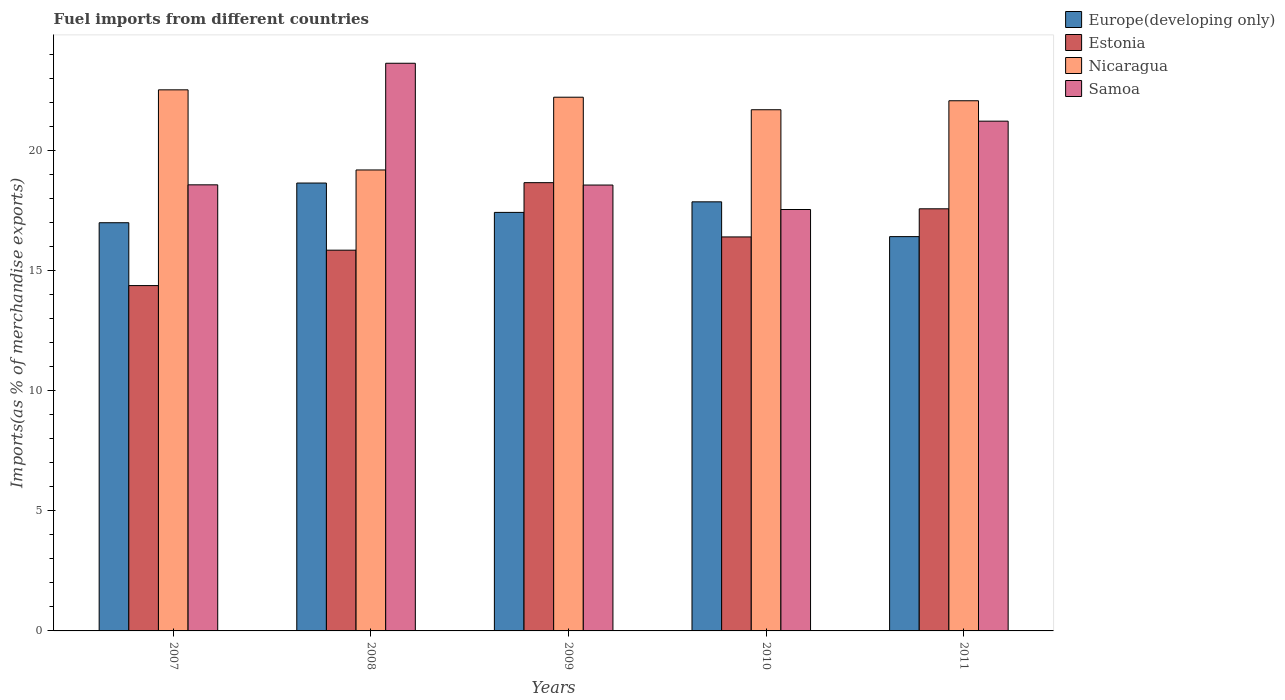How many different coloured bars are there?
Make the answer very short. 4. How many groups of bars are there?
Keep it short and to the point. 5. Are the number of bars per tick equal to the number of legend labels?
Your response must be concise. Yes. Are the number of bars on each tick of the X-axis equal?
Offer a very short reply. Yes. How many bars are there on the 4th tick from the left?
Provide a short and direct response. 4. What is the label of the 5th group of bars from the left?
Your answer should be very brief. 2011. In how many cases, is the number of bars for a given year not equal to the number of legend labels?
Provide a short and direct response. 0. What is the percentage of imports to different countries in Estonia in 2007?
Offer a very short reply. 14.39. Across all years, what is the maximum percentage of imports to different countries in Estonia?
Make the answer very short. 18.67. Across all years, what is the minimum percentage of imports to different countries in Samoa?
Provide a short and direct response. 17.56. In which year was the percentage of imports to different countries in Europe(developing only) maximum?
Give a very brief answer. 2008. What is the total percentage of imports to different countries in Europe(developing only) in the graph?
Offer a terse response. 87.4. What is the difference between the percentage of imports to different countries in Nicaragua in 2008 and that in 2011?
Offer a terse response. -2.88. What is the difference between the percentage of imports to different countries in Samoa in 2008 and the percentage of imports to different countries in Estonia in 2009?
Provide a short and direct response. 4.97. What is the average percentage of imports to different countries in Europe(developing only) per year?
Make the answer very short. 17.48. In the year 2009, what is the difference between the percentage of imports to different countries in Estonia and percentage of imports to different countries in Nicaragua?
Provide a short and direct response. -3.56. In how many years, is the percentage of imports to different countries in Europe(developing only) greater than 20 %?
Your answer should be compact. 0. What is the ratio of the percentage of imports to different countries in Estonia in 2009 to that in 2010?
Your answer should be compact. 1.14. What is the difference between the highest and the second highest percentage of imports to different countries in Estonia?
Your answer should be compact. 1.09. What is the difference between the highest and the lowest percentage of imports to different countries in Samoa?
Your response must be concise. 6.09. What does the 3rd bar from the left in 2011 represents?
Your response must be concise. Nicaragua. What does the 2nd bar from the right in 2009 represents?
Offer a terse response. Nicaragua. How many bars are there?
Offer a terse response. 20. Are all the bars in the graph horizontal?
Provide a short and direct response. No. How many years are there in the graph?
Your response must be concise. 5. What is the difference between two consecutive major ticks on the Y-axis?
Give a very brief answer. 5. Where does the legend appear in the graph?
Your response must be concise. Top right. What is the title of the graph?
Keep it short and to the point. Fuel imports from different countries. Does "World" appear as one of the legend labels in the graph?
Keep it short and to the point. No. What is the label or title of the X-axis?
Provide a short and direct response. Years. What is the label or title of the Y-axis?
Your response must be concise. Imports(as % of merchandise exports). What is the Imports(as % of merchandise exports) in Europe(developing only) in 2007?
Give a very brief answer. 17.01. What is the Imports(as % of merchandise exports) of Estonia in 2007?
Offer a terse response. 14.39. What is the Imports(as % of merchandise exports) of Nicaragua in 2007?
Provide a short and direct response. 22.54. What is the Imports(as % of merchandise exports) in Samoa in 2007?
Provide a short and direct response. 18.58. What is the Imports(as % of merchandise exports) of Europe(developing only) in 2008?
Your answer should be compact. 18.66. What is the Imports(as % of merchandise exports) of Estonia in 2008?
Your response must be concise. 15.86. What is the Imports(as % of merchandise exports) in Nicaragua in 2008?
Offer a very short reply. 19.2. What is the Imports(as % of merchandise exports) of Samoa in 2008?
Give a very brief answer. 23.65. What is the Imports(as % of merchandise exports) of Europe(developing only) in 2009?
Your answer should be very brief. 17.44. What is the Imports(as % of merchandise exports) in Estonia in 2009?
Give a very brief answer. 18.67. What is the Imports(as % of merchandise exports) of Nicaragua in 2009?
Make the answer very short. 22.24. What is the Imports(as % of merchandise exports) in Samoa in 2009?
Provide a short and direct response. 18.58. What is the Imports(as % of merchandise exports) of Europe(developing only) in 2010?
Keep it short and to the point. 17.88. What is the Imports(as % of merchandise exports) of Estonia in 2010?
Your answer should be very brief. 16.41. What is the Imports(as % of merchandise exports) of Nicaragua in 2010?
Offer a very short reply. 21.71. What is the Imports(as % of merchandise exports) of Samoa in 2010?
Provide a short and direct response. 17.56. What is the Imports(as % of merchandise exports) of Europe(developing only) in 2011?
Your response must be concise. 16.43. What is the Imports(as % of merchandise exports) of Estonia in 2011?
Your answer should be compact. 17.59. What is the Imports(as % of merchandise exports) in Nicaragua in 2011?
Your response must be concise. 22.09. What is the Imports(as % of merchandise exports) of Samoa in 2011?
Make the answer very short. 21.24. Across all years, what is the maximum Imports(as % of merchandise exports) in Europe(developing only)?
Give a very brief answer. 18.66. Across all years, what is the maximum Imports(as % of merchandise exports) of Estonia?
Make the answer very short. 18.67. Across all years, what is the maximum Imports(as % of merchandise exports) of Nicaragua?
Provide a succinct answer. 22.54. Across all years, what is the maximum Imports(as % of merchandise exports) in Samoa?
Ensure brevity in your answer.  23.65. Across all years, what is the minimum Imports(as % of merchandise exports) of Europe(developing only)?
Make the answer very short. 16.43. Across all years, what is the minimum Imports(as % of merchandise exports) of Estonia?
Make the answer very short. 14.39. Across all years, what is the minimum Imports(as % of merchandise exports) of Nicaragua?
Ensure brevity in your answer.  19.2. Across all years, what is the minimum Imports(as % of merchandise exports) in Samoa?
Ensure brevity in your answer.  17.56. What is the total Imports(as % of merchandise exports) in Europe(developing only) in the graph?
Offer a terse response. 87.4. What is the total Imports(as % of merchandise exports) in Estonia in the graph?
Make the answer very short. 82.92. What is the total Imports(as % of merchandise exports) of Nicaragua in the graph?
Offer a very short reply. 107.78. What is the total Imports(as % of merchandise exports) in Samoa in the graph?
Your answer should be very brief. 99.6. What is the difference between the Imports(as % of merchandise exports) of Europe(developing only) in 2007 and that in 2008?
Make the answer very short. -1.65. What is the difference between the Imports(as % of merchandise exports) in Estonia in 2007 and that in 2008?
Ensure brevity in your answer.  -1.48. What is the difference between the Imports(as % of merchandise exports) of Nicaragua in 2007 and that in 2008?
Your answer should be compact. 3.34. What is the difference between the Imports(as % of merchandise exports) of Samoa in 2007 and that in 2008?
Offer a very short reply. -5.06. What is the difference between the Imports(as % of merchandise exports) of Europe(developing only) in 2007 and that in 2009?
Make the answer very short. -0.43. What is the difference between the Imports(as % of merchandise exports) of Estonia in 2007 and that in 2009?
Make the answer very short. -4.29. What is the difference between the Imports(as % of merchandise exports) of Nicaragua in 2007 and that in 2009?
Offer a terse response. 0.31. What is the difference between the Imports(as % of merchandise exports) in Samoa in 2007 and that in 2009?
Give a very brief answer. 0.01. What is the difference between the Imports(as % of merchandise exports) in Europe(developing only) in 2007 and that in 2010?
Your response must be concise. -0.87. What is the difference between the Imports(as % of merchandise exports) of Estonia in 2007 and that in 2010?
Give a very brief answer. -2.03. What is the difference between the Imports(as % of merchandise exports) in Nicaragua in 2007 and that in 2010?
Ensure brevity in your answer.  0.83. What is the difference between the Imports(as % of merchandise exports) of Samoa in 2007 and that in 2010?
Offer a very short reply. 1.03. What is the difference between the Imports(as % of merchandise exports) of Europe(developing only) in 2007 and that in 2011?
Your answer should be very brief. 0.58. What is the difference between the Imports(as % of merchandise exports) of Estonia in 2007 and that in 2011?
Your answer should be very brief. -3.2. What is the difference between the Imports(as % of merchandise exports) of Nicaragua in 2007 and that in 2011?
Provide a short and direct response. 0.46. What is the difference between the Imports(as % of merchandise exports) of Samoa in 2007 and that in 2011?
Ensure brevity in your answer.  -2.65. What is the difference between the Imports(as % of merchandise exports) in Europe(developing only) in 2008 and that in 2009?
Offer a very short reply. 1.22. What is the difference between the Imports(as % of merchandise exports) in Estonia in 2008 and that in 2009?
Ensure brevity in your answer.  -2.81. What is the difference between the Imports(as % of merchandise exports) in Nicaragua in 2008 and that in 2009?
Make the answer very short. -3.03. What is the difference between the Imports(as % of merchandise exports) of Samoa in 2008 and that in 2009?
Ensure brevity in your answer.  5.07. What is the difference between the Imports(as % of merchandise exports) of Europe(developing only) in 2008 and that in 2010?
Your answer should be very brief. 0.78. What is the difference between the Imports(as % of merchandise exports) of Estonia in 2008 and that in 2010?
Keep it short and to the point. -0.55. What is the difference between the Imports(as % of merchandise exports) in Nicaragua in 2008 and that in 2010?
Offer a terse response. -2.51. What is the difference between the Imports(as % of merchandise exports) of Samoa in 2008 and that in 2010?
Provide a succinct answer. 6.09. What is the difference between the Imports(as % of merchandise exports) in Europe(developing only) in 2008 and that in 2011?
Offer a very short reply. 2.23. What is the difference between the Imports(as % of merchandise exports) in Estonia in 2008 and that in 2011?
Offer a very short reply. -1.72. What is the difference between the Imports(as % of merchandise exports) of Nicaragua in 2008 and that in 2011?
Provide a succinct answer. -2.88. What is the difference between the Imports(as % of merchandise exports) in Samoa in 2008 and that in 2011?
Offer a terse response. 2.41. What is the difference between the Imports(as % of merchandise exports) in Europe(developing only) in 2009 and that in 2010?
Ensure brevity in your answer.  -0.44. What is the difference between the Imports(as % of merchandise exports) of Estonia in 2009 and that in 2010?
Give a very brief answer. 2.26. What is the difference between the Imports(as % of merchandise exports) in Nicaragua in 2009 and that in 2010?
Keep it short and to the point. 0.52. What is the difference between the Imports(as % of merchandise exports) of Samoa in 2009 and that in 2010?
Offer a terse response. 1.02. What is the difference between the Imports(as % of merchandise exports) of Europe(developing only) in 2009 and that in 2011?
Offer a terse response. 1.01. What is the difference between the Imports(as % of merchandise exports) of Estonia in 2009 and that in 2011?
Make the answer very short. 1.09. What is the difference between the Imports(as % of merchandise exports) of Nicaragua in 2009 and that in 2011?
Offer a very short reply. 0.15. What is the difference between the Imports(as % of merchandise exports) in Samoa in 2009 and that in 2011?
Provide a short and direct response. -2.66. What is the difference between the Imports(as % of merchandise exports) in Europe(developing only) in 2010 and that in 2011?
Offer a terse response. 1.45. What is the difference between the Imports(as % of merchandise exports) in Estonia in 2010 and that in 2011?
Ensure brevity in your answer.  -1.17. What is the difference between the Imports(as % of merchandise exports) of Nicaragua in 2010 and that in 2011?
Your answer should be compact. -0.37. What is the difference between the Imports(as % of merchandise exports) in Samoa in 2010 and that in 2011?
Provide a short and direct response. -3.68. What is the difference between the Imports(as % of merchandise exports) of Europe(developing only) in 2007 and the Imports(as % of merchandise exports) of Estonia in 2008?
Your answer should be very brief. 1.14. What is the difference between the Imports(as % of merchandise exports) in Europe(developing only) in 2007 and the Imports(as % of merchandise exports) in Nicaragua in 2008?
Offer a terse response. -2.2. What is the difference between the Imports(as % of merchandise exports) in Europe(developing only) in 2007 and the Imports(as % of merchandise exports) in Samoa in 2008?
Give a very brief answer. -6.64. What is the difference between the Imports(as % of merchandise exports) of Estonia in 2007 and the Imports(as % of merchandise exports) of Nicaragua in 2008?
Ensure brevity in your answer.  -4.82. What is the difference between the Imports(as % of merchandise exports) of Estonia in 2007 and the Imports(as % of merchandise exports) of Samoa in 2008?
Keep it short and to the point. -9.26. What is the difference between the Imports(as % of merchandise exports) of Nicaragua in 2007 and the Imports(as % of merchandise exports) of Samoa in 2008?
Provide a short and direct response. -1.11. What is the difference between the Imports(as % of merchandise exports) of Europe(developing only) in 2007 and the Imports(as % of merchandise exports) of Estonia in 2009?
Offer a very short reply. -1.67. What is the difference between the Imports(as % of merchandise exports) of Europe(developing only) in 2007 and the Imports(as % of merchandise exports) of Nicaragua in 2009?
Your answer should be compact. -5.23. What is the difference between the Imports(as % of merchandise exports) in Europe(developing only) in 2007 and the Imports(as % of merchandise exports) in Samoa in 2009?
Your answer should be very brief. -1.57. What is the difference between the Imports(as % of merchandise exports) of Estonia in 2007 and the Imports(as % of merchandise exports) of Nicaragua in 2009?
Keep it short and to the point. -7.85. What is the difference between the Imports(as % of merchandise exports) of Estonia in 2007 and the Imports(as % of merchandise exports) of Samoa in 2009?
Keep it short and to the point. -4.19. What is the difference between the Imports(as % of merchandise exports) of Nicaragua in 2007 and the Imports(as % of merchandise exports) of Samoa in 2009?
Provide a short and direct response. 3.97. What is the difference between the Imports(as % of merchandise exports) in Europe(developing only) in 2007 and the Imports(as % of merchandise exports) in Estonia in 2010?
Your answer should be very brief. 0.59. What is the difference between the Imports(as % of merchandise exports) in Europe(developing only) in 2007 and the Imports(as % of merchandise exports) in Nicaragua in 2010?
Your response must be concise. -4.71. What is the difference between the Imports(as % of merchandise exports) in Europe(developing only) in 2007 and the Imports(as % of merchandise exports) in Samoa in 2010?
Offer a terse response. -0.55. What is the difference between the Imports(as % of merchandise exports) in Estonia in 2007 and the Imports(as % of merchandise exports) in Nicaragua in 2010?
Ensure brevity in your answer.  -7.33. What is the difference between the Imports(as % of merchandise exports) in Estonia in 2007 and the Imports(as % of merchandise exports) in Samoa in 2010?
Offer a very short reply. -3.17. What is the difference between the Imports(as % of merchandise exports) in Nicaragua in 2007 and the Imports(as % of merchandise exports) in Samoa in 2010?
Your response must be concise. 4.99. What is the difference between the Imports(as % of merchandise exports) in Europe(developing only) in 2007 and the Imports(as % of merchandise exports) in Estonia in 2011?
Your answer should be very brief. -0.58. What is the difference between the Imports(as % of merchandise exports) of Europe(developing only) in 2007 and the Imports(as % of merchandise exports) of Nicaragua in 2011?
Give a very brief answer. -5.08. What is the difference between the Imports(as % of merchandise exports) in Europe(developing only) in 2007 and the Imports(as % of merchandise exports) in Samoa in 2011?
Give a very brief answer. -4.23. What is the difference between the Imports(as % of merchandise exports) in Estonia in 2007 and the Imports(as % of merchandise exports) in Nicaragua in 2011?
Keep it short and to the point. -7.7. What is the difference between the Imports(as % of merchandise exports) of Estonia in 2007 and the Imports(as % of merchandise exports) of Samoa in 2011?
Your answer should be compact. -6.85. What is the difference between the Imports(as % of merchandise exports) in Nicaragua in 2007 and the Imports(as % of merchandise exports) in Samoa in 2011?
Provide a succinct answer. 1.31. What is the difference between the Imports(as % of merchandise exports) of Europe(developing only) in 2008 and the Imports(as % of merchandise exports) of Estonia in 2009?
Keep it short and to the point. -0.01. What is the difference between the Imports(as % of merchandise exports) in Europe(developing only) in 2008 and the Imports(as % of merchandise exports) in Nicaragua in 2009?
Ensure brevity in your answer.  -3.58. What is the difference between the Imports(as % of merchandise exports) in Europe(developing only) in 2008 and the Imports(as % of merchandise exports) in Samoa in 2009?
Keep it short and to the point. 0.08. What is the difference between the Imports(as % of merchandise exports) of Estonia in 2008 and the Imports(as % of merchandise exports) of Nicaragua in 2009?
Your answer should be very brief. -6.37. What is the difference between the Imports(as % of merchandise exports) of Estonia in 2008 and the Imports(as % of merchandise exports) of Samoa in 2009?
Give a very brief answer. -2.71. What is the difference between the Imports(as % of merchandise exports) of Nicaragua in 2008 and the Imports(as % of merchandise exports) of Samoa in 2009?
Your answer should be compact. 0.63. What is the difference between the Imports(as % of merchandise exports) in Europe(developing only) in 2008 and the Imports(as % of merchandise exports) in Estonia in 2010?
Provide a short and direct response. 2.25. What is the difference between the Imports(as % of merchandise exports) of Europe(developing only) in 2008 and the Imports(as % of merchandise exports) of Nicaragua in 2010?
Give a very brief answer. -3.05. What is the difference between the Imports(as % of merchandise exports) of Europe(developing only) in 2008 and the Imports(as % of merchandise exports) of Samoa in 2010?
Provide a short and direct response. 1.1. What is the difference between the Imports(as % of merchandise exports) of Estonia in 2008 and the Imports(as % of merchandise exports) of Nicaragua in 2010?
Offer a terse response. -5.85. What is the difference between the Imports(as % of merchandise exports) in Estonia in 2008 and the Imports(as % of merchandise exports) in Samoa in 2010?
Make the answer very short. -1.69. What is the difference between the Imports(as % of merchandise exports) in Nicaragua in 2008 and the Imports(as % of merchandise exports) in Samoa in 2010?
Offer a terse response. 1.65. What is the difference between the Imports(as % of merchandise exports) in Europe(developing only) in 2008 and the Imports(as % of merchandise exports) in Estonia in 2011?
Keep it short and to the point. 1.07. What is the difference between the Imports(as % of merchandise exports) of Europe(developing only) in 2008 and the Imports(as % of merchandise exports) of Nicaragua in 2011?
Make the answer very short. -3.43. What is the difference between the Imports(as % of merchandise exports) in Europe(developing only) in 2008 and the Imports(as % of merchandise exports) in Samoa in 2011?
Your answer should be compact. -2.58. What is the difference between the Imports(as % of merchandise exports) of Estonia in 2008 and the Imports(as % of merchandise exports) of Nicaragua in 2011?
Provide a short and direct response. -6.22. What is the difference between the Imports(as % of merchandise exports) in Estonia in 2008 and the Imports(as % of merchandise exports) in Samoa in 2011?
Keep it short and to the point. -5.37. What is the difference between the Imports(as % of merchandise exports) in Nicaragua in 2008 and the Imports(as % of merchandise exports) in Samoa in 2011?
Give a very brief answer. -2.03. What is the difference between the Imports(as % of merchandise exports) in Europe(developing only) in 2009 and the Imports(as % of merchandise exports) in Estonia in 2010?
Your answer should be compact. 1.02. What is the difference between the Imports(as % of merchandise exports) in Europe(developing only) in 2009 and the Imports(as % of merchandise exports) in Nicaragua in 2010?
Keep it short and to the point. -4.28. What is the difference between the Imports(as % of merchandise exports) in Europe(developing only) in 2009 and the Imports(as % of merchandise exports) in Samoa in 2010?
Offer a very short reply. -0.12. What is the difference between the Imports(as % of merchandise exports) of Estonia in 2009 and the Imports(as % of merchandise exports) of Nicaragua in 2010?
Offer a very short reply. -3.04. What is the difference between the Imports(as % of merchandise exports) in Estonia in 2009 and the Imports(as % of merchandise exports) in Samoa in 2010?
Keep it short and to the point. 1.12. What is the difference between the Imports(as % of merchandise exports) in Nicaragua in 2009 and the Imports(as % of merchandise exports) in Samoa in 2010?
Provide a succinct answer. 4.68. What is the difference between the Imports(as % of merchandise exports) of Europe(developing only) in 2009 and the Imports(as % of merchandise exports) of Estonia in 2011?
Your response must be concise. -0.15. What is the difference between the Imports(as % of merchandise exports) of Europe(developing only) in 2009 and the Imports(as % of merchandise exports) of Nicaragua in 2011?
Make the answer very short. -4.65. What is the difference between the Imports(as % of merchandise exports) in Europe(developing only) in 2009 and the Imports(as % of merchandise exports) in Samoa in 2011?
Make the answer very short. -3.8. What is the difference between the Imports(as % of merchandise exports) of Estonia in 2009 and the Imports(as % of merchandise exports) of Nicaragua in 2011?
Make the answer very short. -3.41. What is the difference between the Imports(as % of merchandise exports) of Estonia in 2009 and the Imports(as % of merchandise exports) of Samoa in 2011?
Your answer should be compact. -2.56. What is the difference between the Imports(as % of merchandise exports) of Nicaragua in 2009 and the Imports(as % of merchandise exports) of Samoa in 2011?
Offer a very short reply. 1. What is the difference between the Imports(as % of merchandise exports) in Europe(developing only) in 2010 and the Imports(as % of merchandise exports) in Estonia in 2011?
Your answer should be compact. 0.29. What is the difference between the Imports(as % of merchandise exports) in Europe(developing only) in 2010 and the Imports(as % of merchandise exports) in Nicaragua in 2011?
Make the answer very short. -4.21. What is the difference between the Imports(as % of merchandise exports) of Europe(developing only) in 2010 and the Imports(as % of merchandise exports) of Samoa in 2011?
Provide a short and direct response. -3.36. What is the difference between the Imports(as % of merchandise exports) in Estonia in 2010 and the Imports(as % of merchandise exports) in Nicaragua in 2011?
Make the answer very short. -5.67. What is the difference between the Imports(as % of merchandise exports) of Estonia in 2010 and the Imports(as % of merchandise exports) of Samoa in 2011?
Your response must be concise. -4.82. What is the difference between the Imports(as % of merchandise exports) of Nicaragua in 2010 and the Imports(as % of merchandise exports) of Samoa in 2011?
Ensure brevity in your answer.  0.48. What is the average Imports(as % of merchandise exports) in Europe(developing only) per year?
Provide a succinct answer. 17.48. What is the average Imports(as % of merchandise exports) in Estonia per year?
Offer a very short reply. 16.58. What is the average Imports(as % of merchandise exports) of Nicaragua per year?
Provide a succinct answer. 21.56. What is the average Imports(as % of merchandise exports) of Samoa per year?
Make the answer very short. 19.92. In the year 2007, what is the difference between the Imports(as % of merchandise exports) of Europe(developing only) and Imports(as % of merchandise exports) of Estonia?
Your answer should be very brief. 2.62. In the year 2007, what is the difference between the Imports(as % of merchandise exports) of Europe(developing only) and Imports(as % of merchandise exports) of Nicaragua?
Provide a short and direct response. -5.54. In the year 2007, what is the difference between the Imports(as % of merchandise exports) in Europe(developing only) and Imports(as % of merchandise exports) in Samoa?
Your answer should be compact. -1.58. In the year 2007, what is the difference between the Imports(as % of merchandise exports) in Estonia and Imports(as % of merchandise exports) in Nicaragua?
Ensure brevity in your answer.  -8.16. In the year 2007, what is the difference between the Imports(as % of merchandise exports) in Estonia and Imports(as % of merchandise exports) in Samoa?
Provide a short and direct response. -4.2. In the year 2007, what is the difference between the Imports(as % of merchandise exports) of Nicaragua and Imports(as % of merchandise exports) of Samoa?
Your answer should be compact. 3.96. In the year 2008, what is the difference between the Imports(as % of merchandise exports) of Europe(developing only) and Imports(as % of merchandise exports) of Estonia?
Offer a terse response. 2.8. In the year 2008, what is the difference between the Imports(as % of merchandise exports) of Europe(developing only) and Imports(as % of merchandise exports) of Nicaragua?
Offer a very short reply. -0.54. In the year 2008, what is the difference between the Imports(as % of merchandise exports) in Europe(developing only) and Imports(as % of merchandise exports) in Samoa?
Keep it short and to the point. -4.99. In the year 2008, what is the difference between the Imports(as % of merchandise exports) in Estonia and Imports(as % of merchandise exports) in Nicaragua?
Your response must be concise. -3.34. In the year 2008, what is the difference between the Imports(as % of merchandise exports) of Estonia and Imports(as % of merchandise exports) of Samoa?
Provide a short and direct response. -7.79. In the year 2008, what is the difference between the Imports(as % of merchandise exports) of Nicaragua and Imports(as % of merchandise exports) of Samoa?
Make the answer very short. -4.45. In the year 2009, what is the difference between the Imports(as % of merchandise exports) in Europe(developing only) and Imports(as % of merchandise exports) in Estonia?
Your answer should be very brief. -1.24. In the year 2009, what is the difference between the Imports(as % of merchandise exports) of Europe(developing only) and Imports(as % of merchandise exports) of Nicaragua?
Provide a short and direct response. -4.8. In the year 2009, what is the difference between the Imports(as % of merchandise exports) in Europe(developing only) and Imports(as % of merchandise exports) in Samoa?
Offer a very short reply. -1.14. In the year 2009, what is the difference between the Imports(as % of merchandise exports) in Estonia and Imports(as % of merchandise exports) in Nicaragua?
Provide a succinct answer. -3.56. In the year 2009, what is the difference between the Imports(as % of merchandise exports) of Estonia and Imports(as % of merchandise exports) of Samoa?
Provide a succinct answer. 0.1. In the year 2009, what is the difference between the Imports(as % of merchandise exports) of Nicaragua and Imports(as % of merchandise exports) of Samoa?
Give a very brief answer. 3.66. In the year 2010, what is the difference between the Imports(as % of merchandise exports) in Europe(developing only) and Imports(as % of merchandise exports) in Estonia?
Make the answer very short. 1.46. In the year 2010, what is the difference between the Imports(as % of merchandise exports) in Europe(developing only) and Imports(as % of merchandise exports) in Nicaragua?
Offer a very short reply. -3.84. In the year 2010, what is the difference between the Imports(as % of merchandise exports) of Europe(developing only) and Imports(as % of merchandise exports) of Samoa?
Give a very brief answer. 0.32. In the year 2010, what is the difference between the Imports(as % of merchandise exports) in Estonia and Imports(as % of merchandise exports) in Nicaragua?
Your response must be concise. -5.3. In the year 2010, what is the difference between the Imports(as % of merchandise exports) of Estonia and Imports(as % of merchandise exports) of Samoa?
Make the answer very short. -1.14. In the year 2010, what is the difference between the Imports(as % of merchandise exports) in Nicaragua and Imports(as % of merchandise exports) in Samoa?
Keep it short and to the point. 4.16. In the year 2011, what is the difference between the Imports(as % of merchandise exports) in Europe(developing only) and Imports(as % of merchandise exports) in Estonia?
Keep it short and to the point. -1.16. In the year 2011, what is the difference between the Imports(as % of merchandise exports) in Europe(developing only) and Imports(as % of merchandise exports) in Nicaragua?
Make the answer very short. -5.66. In the year 2011, what is the difference between the Imports(as % of merchandise exports) of Europe(developing only) and Imports(as % of merchandise exports) of Samoa?
Give a very brief answer. -4.81. In the year 2011, what is the difference between the Imports(as % of merchandise exports) of Estonia and Imports(as % of merchandise exports) of Nicaragua?
Your response must be concise. -4.5. In the year 2011, what is the difference between the Imports(as % of merchandise exports) of Estonia and Imports(as % of merchandise exports) of Samoa?
Provide a succinct answer. -3.65. In the year 2011, what is the difference between the Imports(as % of merchandise exports) in Nicaragua and Imports(as % of merchandise exports) in Samoa?
Your answer should be very brief. 0.85. What is the ratio of the Imports(as % of merchandise exports) of Europe(developing only) in 2007 to that in 2008?
Provide a short and direct response. 0.91. What is the ratio of the Imports(as % of merchandise exports) in Estonia in 2007 to that in 2008?
Keep it short and to the point. 0.91. What is the ratio of the Imports(as % of merchandise exports) in Nicaragua in 2007 to that in 2008?
Your response must be concise. 1.17. What is the ratio of the Imports(as % of merchandise exports) of Samoa in 2007 to that in 2008?
Keep it short and to the point. 0.79. What is the ratio of the Imports(as % of merchandise exports) in Europe(developing only) in 2007 to that in 2009?
Offer a terse response. 0.98. What is the ratio of the Imports(as % of merchandise exports) of Estonia in 2007 to that in 2009?
Your answer should be very brief. 0.77. What is the ratio of the Imports(as % of merchandise exports) in Nicaragua in 2007 to that in 2009?
Offer a very short reply. 1.01. What is the ratio of the Imports(as % of merchandise exports) of Samoa in 2007 to that in 2009?
Provide a short and direct response. 1. What is the ratio of the Imports(as % of merchandise exports) in Europe(developing only) in 2007 to that in 2010?
Provide a succinct answer. 0.95. What is the ratio of the Imports(as % of merchandise exports) in Estonia in 2007 to that in 2010?
Ensure brevity in your answer.  0.88. What is the ratio of the Imports(as % of merchandise exports) in Nicaragua in 2007 to that in 2010?
Offer a very short reply. 1.04. What is the ratio of the Imports(as % of merchandise exports) in Samoa in 2007 to that in 2010?
Give a very brief answer. 1.06. What is the ratio of the Imports(as % of merchandise exports) of Europe(developing only) in 2007 to that in 2011?
Provide a short and direct response. 1.04. What is the ratio of the Imports(as % of merchandise exports) in Estonia in 2007 to that in 2011?
Your answer should be compact. 0.82. What is the ratio of the Imports(as % of merchandise exports) of Nicaragua in 2007 to that in 2011?
Give a very brief answer. 1.02. What is the ratio of the Imports(as % of merchandise exports) in Samoa in 2007 to that in 2011?
Make the answer very short. 0.88. What is the ratio of the Imports(as % of merchandise exports) in Europe(developing only) in 2008 to that in 2009?
Your answer should be very brief. 1.07. What is the ratio of the Imports(as % of merchandise exports) of Estonia in 2008 to that in 2009?
Ensure brevity in your answer.  0.85. What is the ratio of the Imports(as % of merchandise exports) in Nicaragua in 2008 to that in 2009?
Your answer should be compact. 0.86. What is the ratio of the Imports(as % of merchandise exports) of Samoa in 2008 to that in 2009?
Keep it short and to the point. 1.27. What is the ratio of the Imports(as % of merchandise exports) in Europe(developing only) in 2008 to that in 2010?
Offer a terse response. 1.04. What is the ratio of the Imports(as % of merchandise exports) of Estonia in 2008 to that in 2010?
Provide a short and direct response. 0.97. What is the ratio of the Imports(as % of merchandise exports) of Nicaragua in 2008 to that in 2010?
Provide a short and direct response. 0.88. What is the ratio of the Imports(as % of merchandise exports) in Samoa in 2008 to that in 2010?
Offer a very short reply. 1.35. What is the ratio of the Imports(as % of merchandise exports) of Europe(developing only) in 2008 to that in 2011?
Your answer should be very brief. 1.14. What is the ratio of the Imports(as % of merchandise exports) in Estonia in 2008 to that in 2011?
Your response must be concise. 0.9. What is the ratio of the Imports(as % of merchandise exports) in Nicaragua in 2008 to that in 2011?
Give a very brief answer. 0.87. What is the ratio of the Imports(as % of merchandise exports) in Samoa in 2008 to that in 2011?
Your response must be concise. 1.11. What is the ratio of the Imports(as % of merchandise exports) in Europe(developing only) in 2009 to that in 2010?
Give a very brief answer. 0.98. What is the ratio of the Imports(as % of merchandise exports) in Estonia in 2009 to that in 2010?
Ensure brevity in your answer.  1.14. What is the ratio of the Imports(as % of merchandise exports) of Nicaragua in 2009 to that in 2010?
Provide a short and direct response. 1.02. What is the ratio of the Imports(as % of merchandise exports) in Samoa in 2009 to that in 2010?
Make the answer very short. 1.06. What is the ratio of the Imports(as % of merchandise exports) in Europe(developing only) in 2009 to that in 2011?
Give a very brief answer. 1.06. What is the ratio of the Imports(as % of merchandise exports) of Estonia in 2009 to that in 2011?
Offer a very short reply. 1.06. What is the ratio of the Imports(as % of merchandise exports) in Samoa in 2009 to that in 2011?
Provide a short and direct response. 0.87. What is the ratio of the Imports(as % of merchandise exports) of Europe(developing only) in 2010 to that in 2011?
Your answer should be compact. 1.09. What is the ratio of the Imports(as % of merchandise exports) in Estonia in 2010 to that in 2011?
Ensure brevity in your answer.  0.93. What is the ratio of the Imports(as % of merchandise exports) in Nicaragua in 2010 to that in 2011?
Give a very brief answer. 0.98. What is the ratio of the Imports(as % of merchandise exports) in Samoa in 2010 to that in 2011?
Your answer should be compact. 0.83. What is the difference between the highest and the second highest Imports(as % of merchandise exports) of Europe(developing only)?
Offer a very short reply. 0.78. What is the difference between the highest and the second highest Imports(as % of merchandise exports) in Estonia?
Offer a terse response. 1.09. What is the difference between the highest and the second highest Imports(as % of merchandise exports) of Nicaragua?
Provide a short and direct response. 0.31. What is the difference between the highest and the second highest Imports(as % of merchandise exports) of Samoa?
Keep it short and to the point. 2.41. What is the difference between the highest and the lowest Imports(as % of merchandise exports) in Europe(developing only)?
Make the answer very short. 2.23. What is the difference between the highest and the lowest Imports(as % of merchandise exports) in Estonia?
Ensure brevity in your answer.  4.29. What is the difference between the highest and the lowest Imports(as % of merchandise exports) in Nicaragua?
Your answer should be compact. 3.34. What is the difference between the highest and the lowest Imports(as % of merchandise exports) of Samoa?
Ensure brevity in your answer.  6.09. 